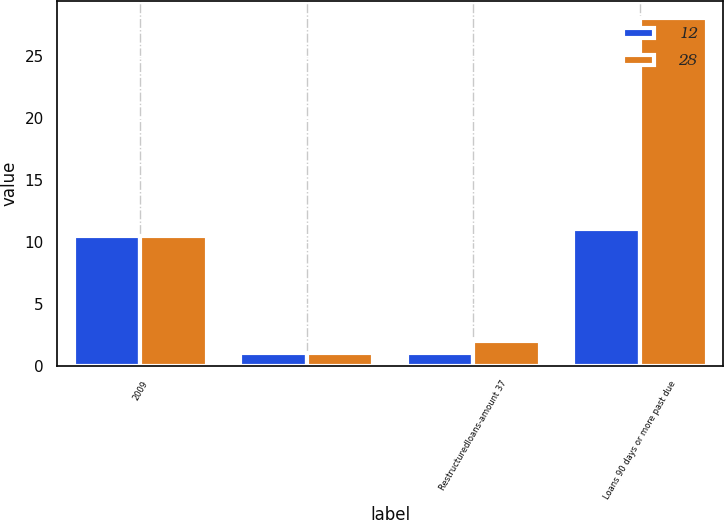Convert chart. <chart><loc_0><loc_0><loc_500><loc_500><stacked_bar_chart><ecel><fcel>2009<fcel>Unnamed: 2<fcel>Restructuredloans-amount 37<fcel>Loans 90 days or more past due<nl><fcel>12<fcel>10.5<fcel>1<fcel>1<fcel>11<nl><fcel>28<fcel>10.5<fcel>1<fcel>2<fcel>28<nl></chart> 